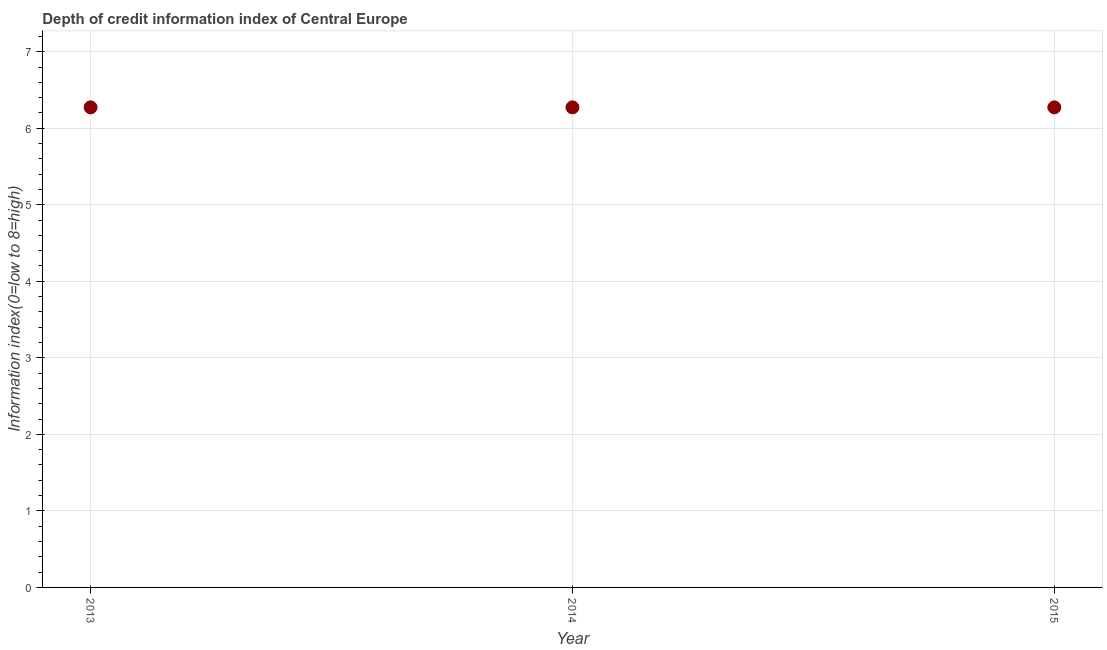What is the depth of credit information index in 2015?
Your response must be concise. 6.27. Across all years, what is the maximum depth of credit information index?
Offer a terse response. 6.27. Across all years, what is the minimum depth of credit information index?
Give a very brief answer. 6.27. In which year was the depth of credit information index maximum?
Keep it short and to the point. 2013. In which year was the depth of credit information index minimum?
Keep it short and to the point. 2013. What is the sum of the depth of credit information index?
Offer a very short reply. 18.82. What is the average depth of credit information index per year?
Make the answer very short. 6.27. What is the median depth of credit information index?
Keep it short and to the point. 6.27. In how many years, is the depth of credit information index greater than 0.8 ?
Your response must be concise. 3. Is the difference between the depth of credit information index in 2014 and 2015 greater than the difference between any two years?
Your response must be concise. Yes. What is the difference between the highest and the second highest depth of credit information index?
Provide a short and direct response. 0. Is the sum of the depth of credit information index in 2013 and 2014 greater than the maximum depth of credit information index across all years?
Provide a short and direct response. Yes. Does the depth of credit information index monotonically increase over the years?
Offer a very short reply. No. How many dotlines are there?
Provide a short and direct response. 1. How many years are there in the graph?
Provide a succinct answer. 3. Does the graph contain any zero values?
Make the answer very short. No. Does the graph contain grids?
Ensure brevity in your answer.  Yes. What is the title of the graph?
Make the answer very short. Depth of credit information index of Central Europe. What is the label or title of the Y-axis?
Provide a succinct answer. Information index(0=low to 8=high). What is the Information index(0=low to 8=high) in 2013?
Your answer should be very brief. 6.27. What is the Information index(0=low to 8=high) in 2014?
Make the answer very short. 6.27. What is the Information index(0=low to 8=high) in 2015?
Provide a short and direct response. 6.27. What is the difference between the Information index(0=low to 8=high) in 2014 and 2015?
Make the answer very short. 0. 